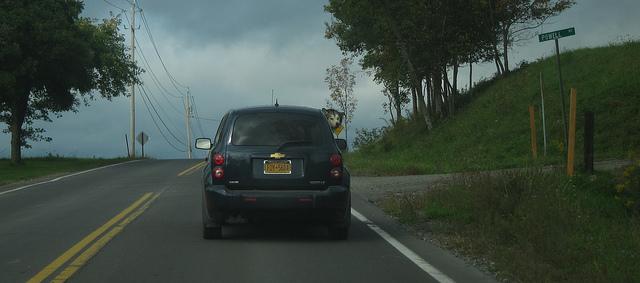What kind of car is that?
Keep it brief. Chevrolet. How many cars are there?
Give a very brief answer. 1. What time of day is this?
Short answer required. Evening. What kind of sign is in the picture?
Answer briefly. Street sign. How many street signs are there?
Short answer required. 3. What is sticking out of the window of the car?
Short answer required. Dog. What color is the ground?
Concise answer only. Green. How many cars are visible in this photo?
Concise answer only. 1. Is the trunk open?
Be succinct. No. 